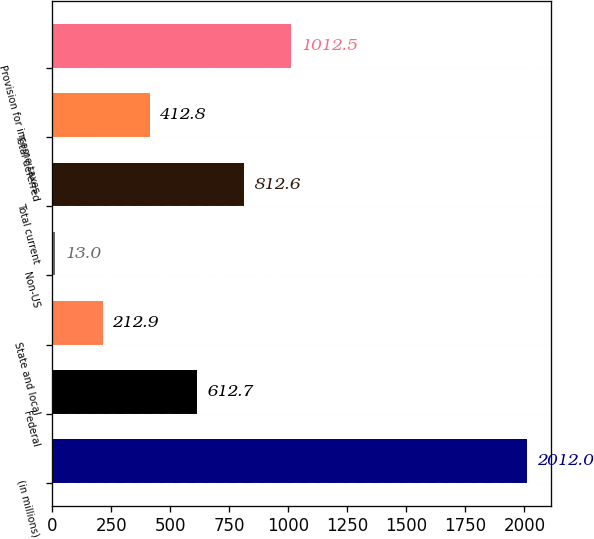<chart> <loc_0><loc_0><loc_500><loc_500><bar_chart><fcel>(in millions)<fcel>Federal<fcel>State and local<fcel>Non-US<fcel>Total current<fcel>Total deferred<fcel>Provision for income taxes<nl><fcel>2012<fcel>612.7<fcel>212.9<fcel>13<fcel>812.6<fcel>412.8<fcel>1012.5<nl></chart> 